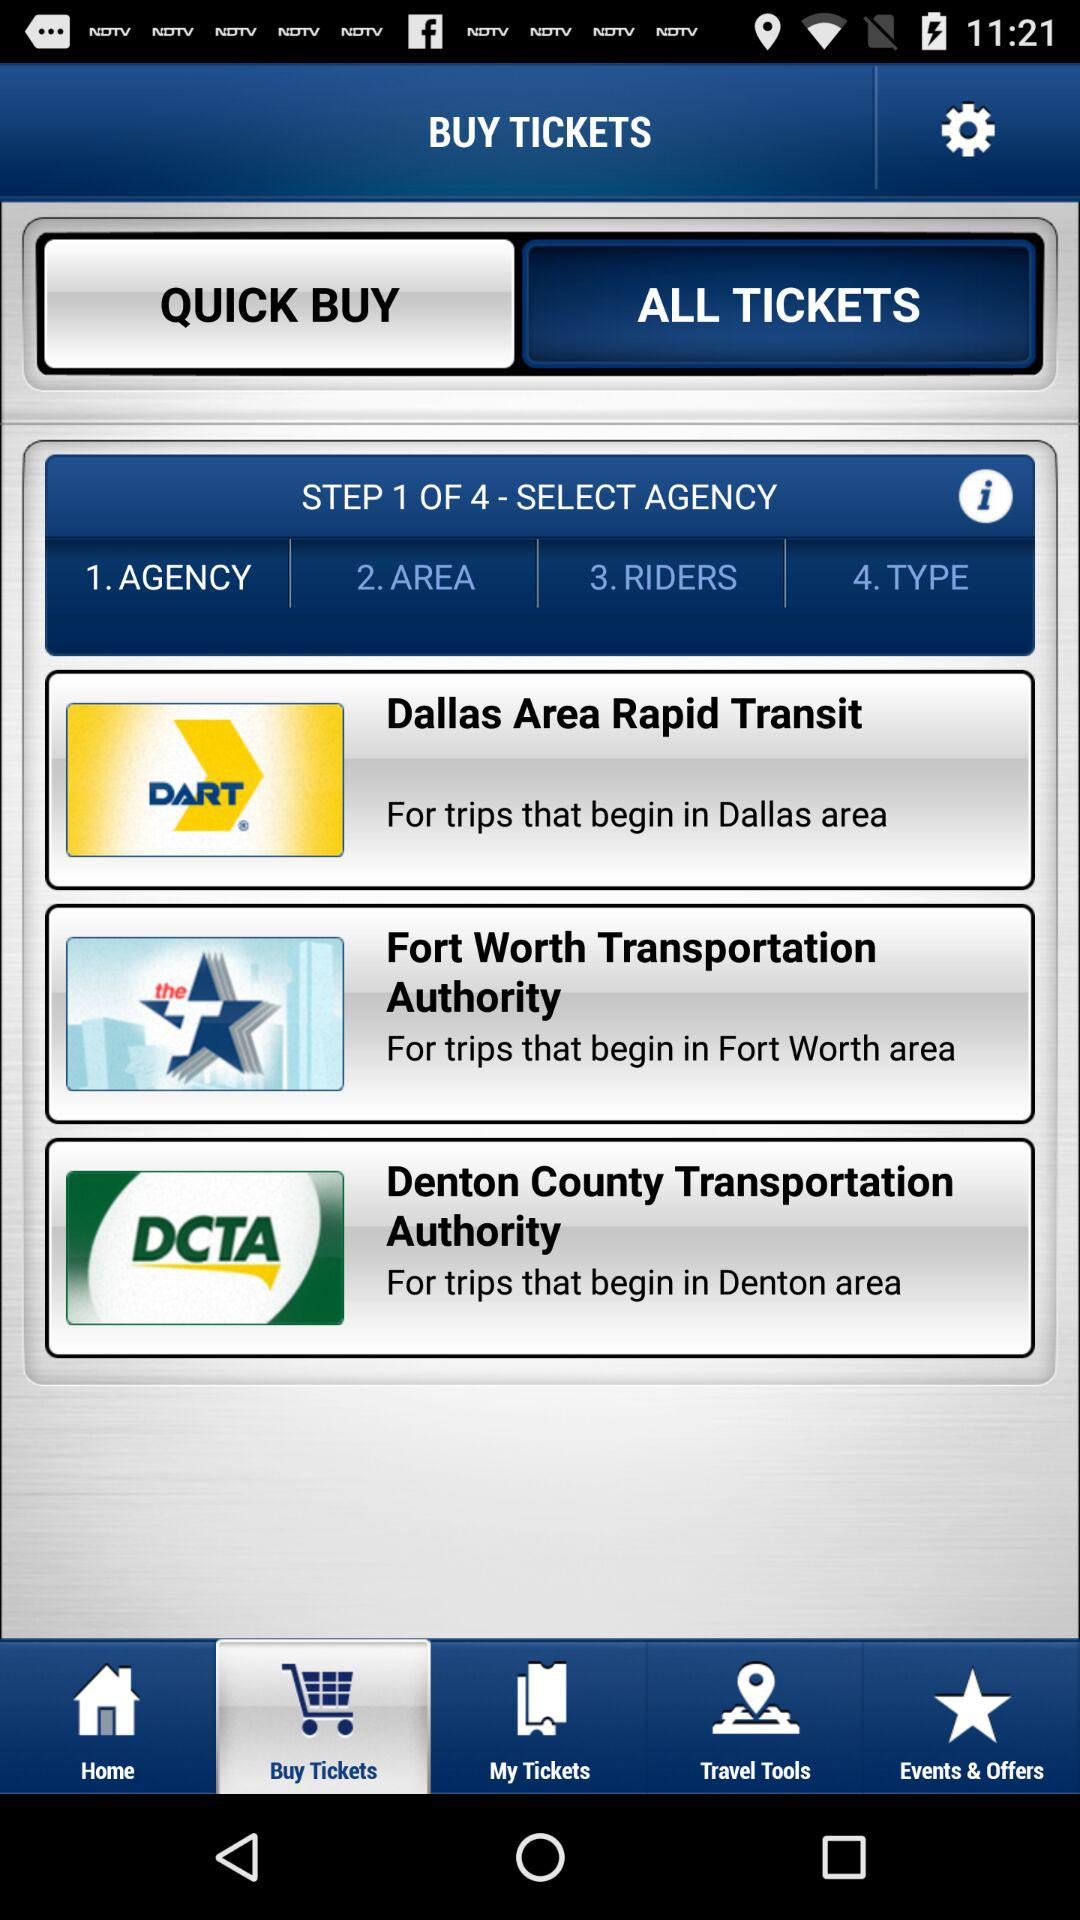What other features does this app provide besides buying tickets? Apart from purchasing tickets, this app offers several convenient features. You can manage your tickets under 'My Tickets', use 'Travel Tools' for planning trips and navigating schedules, and view 'Events & Offers' to discover special deals and services. 